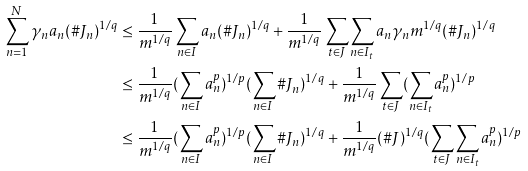Convert formula to latex. <formula><loc_0><loc_0><loc_500><loc_500>\sum _ { n = 1 } ^ { N } \gamma _ { n } a _ { n } ( \# J _ { n } ) ^ { 1 / q } & \leq \frac { 1 } { m ^ { 1 / q } } \sum _ { n \in I } a _ { n } ( \# J _ { n } ) ^ { 1 / q } + \frac { 1 } { m ^ { 1 / q } } \sum _ { t \in J } \sum _ { n \in I _ { t } } a _ { n } \gamma _ { n } m ^ { 1 / q } ( \# J _ { n } ) ^ { 1 / q } \\ & \leq \frac { 1 } { m ^ { 1 / q } } ( \sum _ { n \in I } a _ { n } ^ { p } ) ^ { 1 / p } ( \sum _ { n \in I } \# J _ { n } ) ^ { 1 / q } + \frac { 1 } { m ^ { 1 / q } } \sum _ { t \in J } ( \sum _ { n \in I _ { t } } a _ { n } ^ { p } ) ^ { 1 / p } \\ & \leq \frac { 1 } { m ^ { 1 / q } } ( \sum _ { n \in I } a _ { n } ^ { p } ) ^ { 1 / p } ( \sum _ { n \in I } \# J _ { n } ) ^ { 1 / q } + \frac { 1 } { m ^ { 1 / q } } ( \# J ) ^ { 1 / q } ( \sum _ { t \in J } \sum _ { n \in I _ { t } } a _ { n } ^ { p } ) ^ { 1 / p }</formula> 